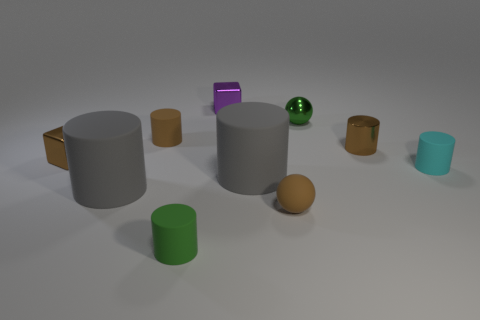Do the cyan cylinder and the tiny green thing that is in front of the tiny matte ball have the same material? Yes, the cyan cylinder and the tiny green object, which appears to be a cube, both have a similar matte finish, suggesting they are made from the same or similar materials. 